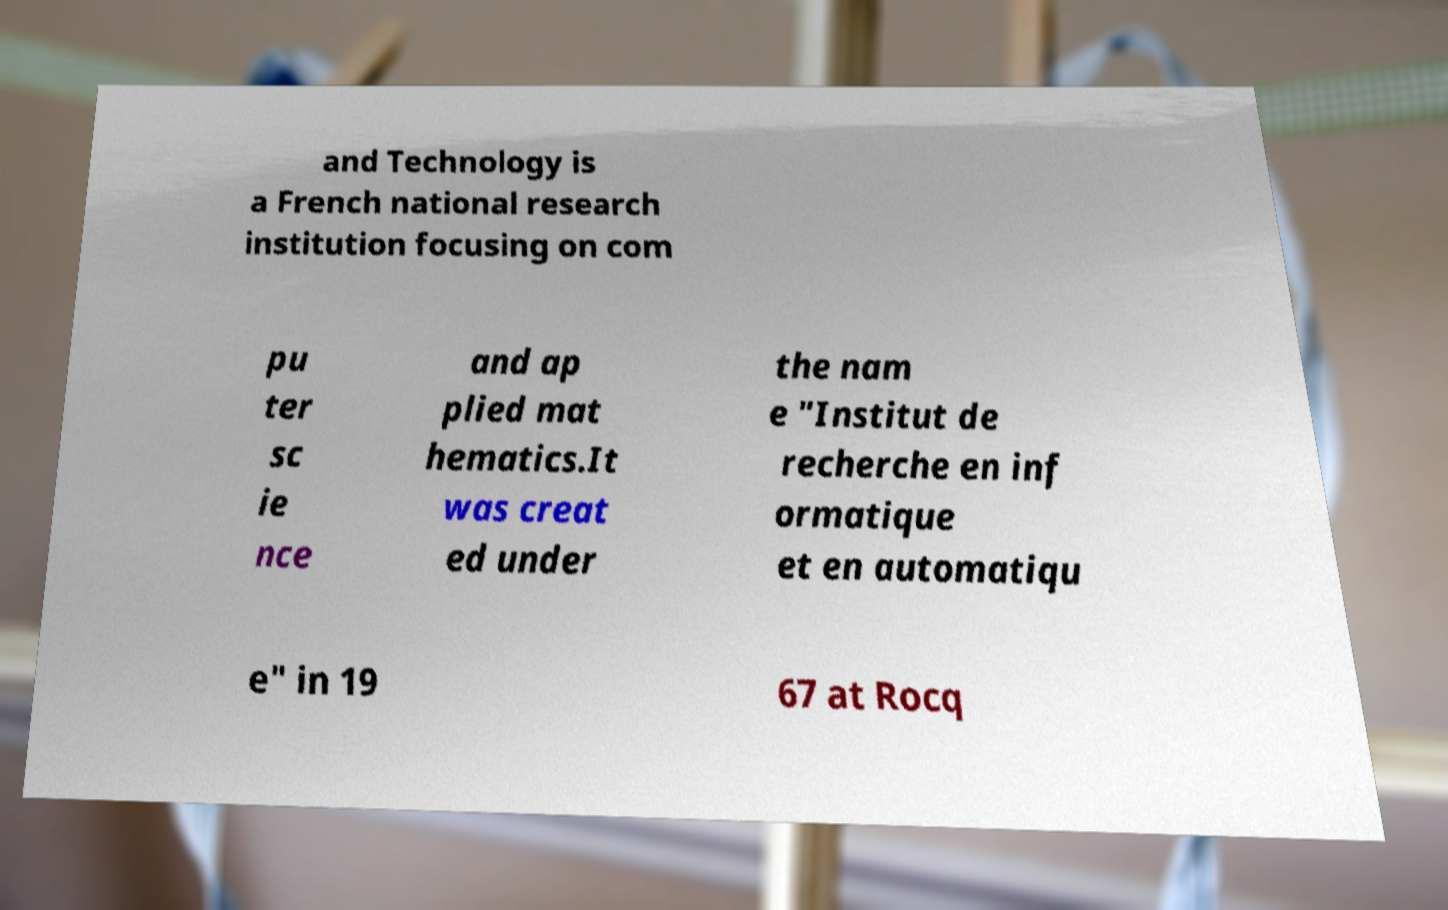Could you extract and type out the text from this image? and Technology is a French national research institution focusing on com pu ter sc ie nce and ap plied mat hematics.It was creat ed under the nam e "Institut de recherche en inf ormatique et en automatiqu e" in 19 67 at Rocq 